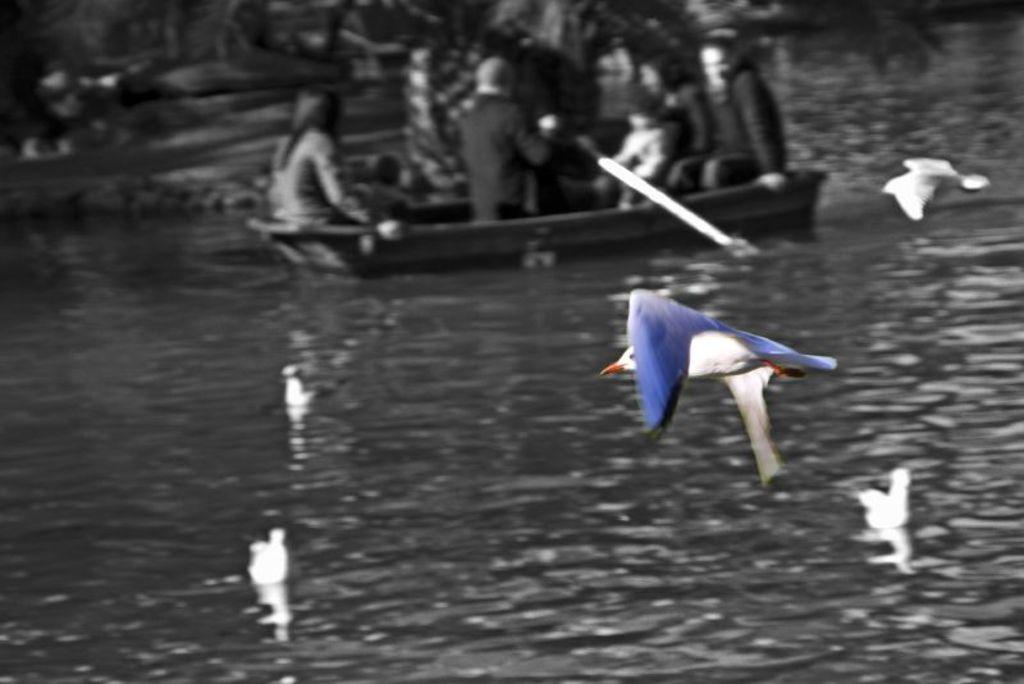Please provide a concise description of this image. In this image there are birds and we can see water. There is a boat on the water and we can see people sitting in the boat. 